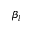<formula> <loc_0><loc_0><loc_500><loc_500>\beta _ { l }</formula> 